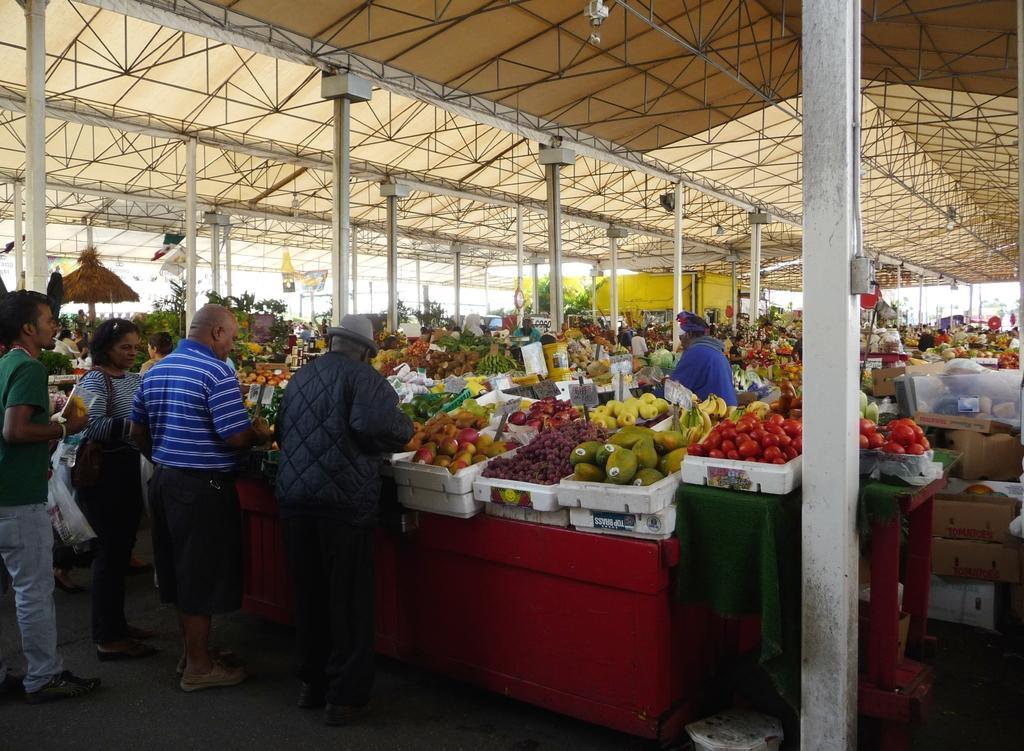How would you summarize this image in a sentence or two? In this picture we can see some people standing on the ground, plastic cover, boxes, tables, poles, rods, shelter, baskets with fruits in it such as bananas, apples and some objects. 